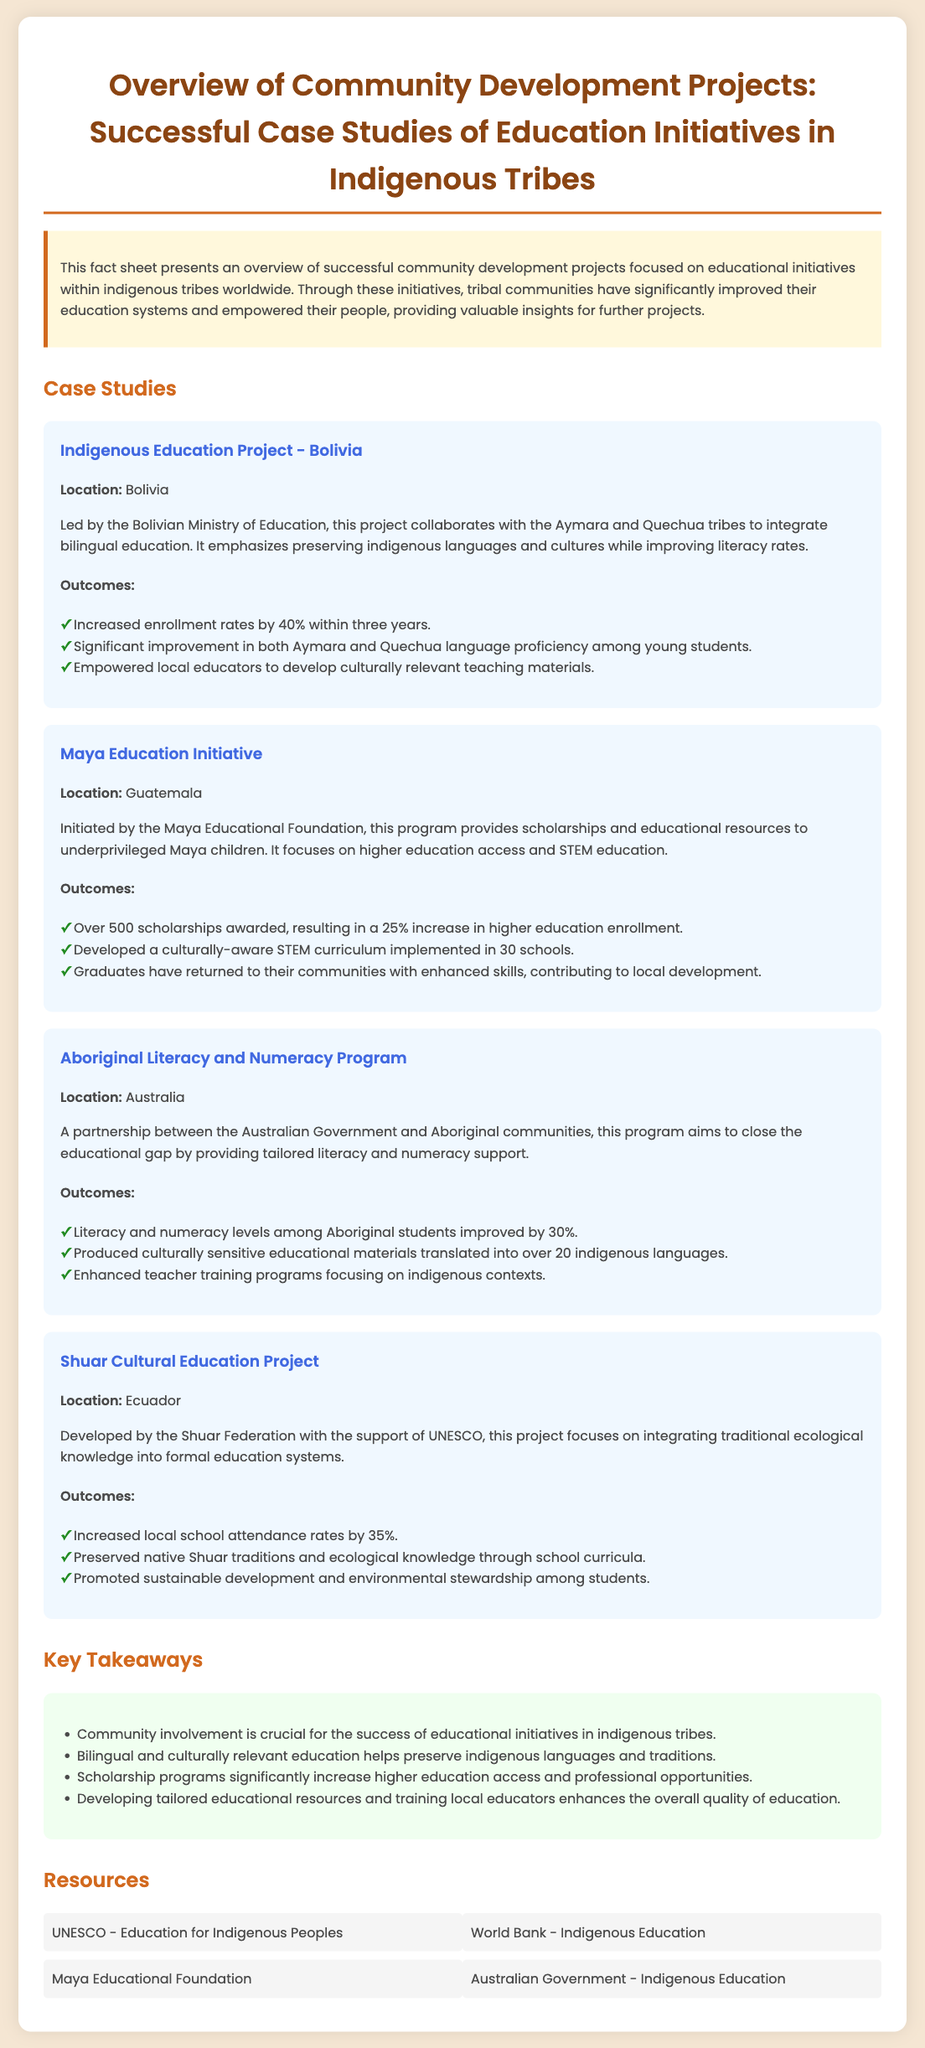What is the title of the document? The title of the document is provided at the top of the fact sheet.
Answer: Overview of Community Development Projects: Successful Case Studies of Education Initiatives in Indigenous Tribes Which tribes are involved in the Indigenous Education Project? The document specifies that the project involves the Aymara and Quechua tribes.
Answer: Aymara and Quechua What was the increase in enrollment rates for the Indigenous Education Project? The document states that there was a 40% increase in enrollment rates within three years.
Answer: 40% How many scholarships were awarded in the Maya Education Initiative? The document mentions that over 500 scholarships were awarded in the initiative.
Answer: Over 500 What percentage improvement in literacy and numeracy levels was reported in the Aboriginal Literacy and Numeracy Program? The document indicates a 30% improvement in literacy and numeracy levels.
Answer: 30% What key aspect does the Shuar Cultural Education Project emphasize? The document highlights the integration of traditional ecological knowledge into formal education systems.
Answer: Traditional ecological knowledge What is a significant takeaway from the fact sheet? The document lists several key takeaways, one being that community involvement is crucial.
Answer: Community involvement Which organization supports the Shuar Cultural Education Project? The document specifies that the project is supported by UNESCO.
Answer: UNESCO 